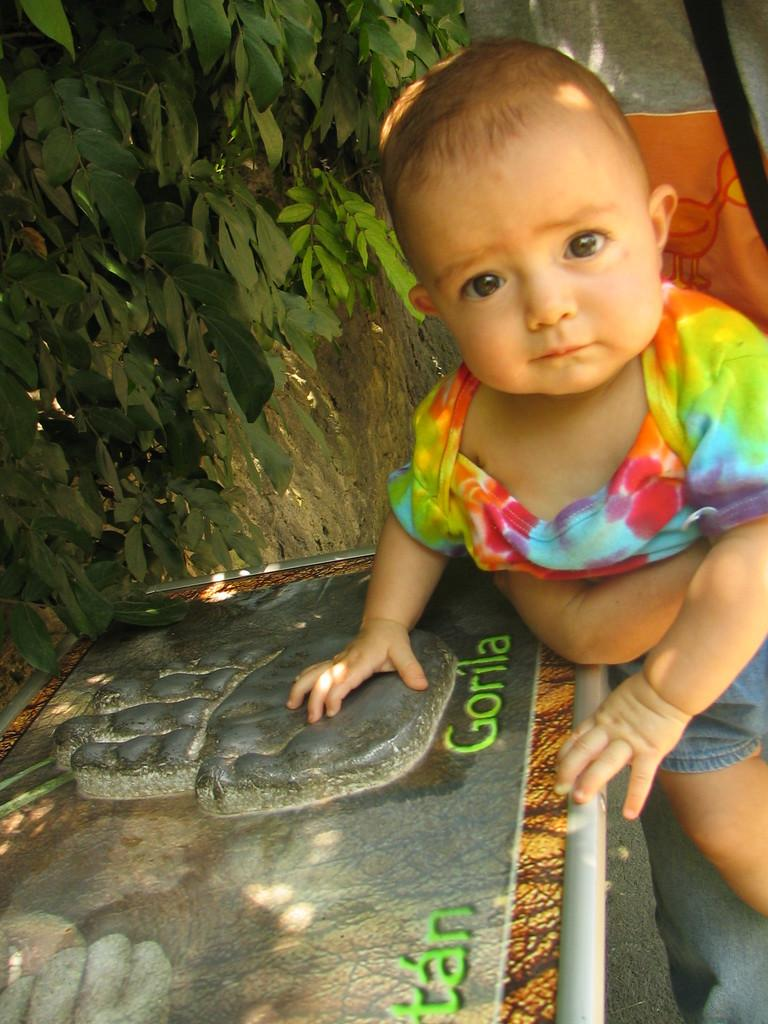What is happening on the right side of the image? There is a person holding a kid on the right side of the image. What is located at the bottom of the image? There is a board and a floor visible at the bottom of the image. What can be seen in the background of the image? There is a tree and cloth visible in the background of the image. What is the tendency of the group in the image? There is no group present in the image, so it's not possible to determine any tendencies. 